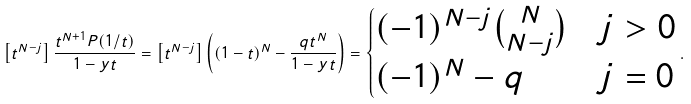Convert formula to latex. <formula><loc_0><loc_0><loc_500><loc_500>\left [ t ^ { N - j } \right ] \frac { t ^ { N + 1 } P ( 1 / t ) } { 1 - y t } = \left [ t ^ { N - j } \right ] \left ( ( 1 - t ) ^ { N } - \frac { q t ^ { N } } { 1 - y t } \right ) = \begin{cases} ( - 1 ) ^ { N - j } \binom { N } { N - j } & j > 0 \\ ( - 1 ) ^ { N } - q & j = 0 \end{cases} .</formula> 